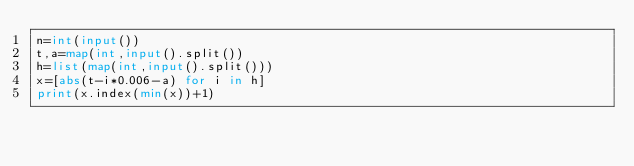<code> <loc_0><loc_0><loc_500><loc_500><_Python_>n=int(input())
t,a=map(int,input().split())
h=list(map(int,input().split()))
x=[abs(t-i*0.006-a) for i in h]
print(x.index(min(x))+1)</code> 